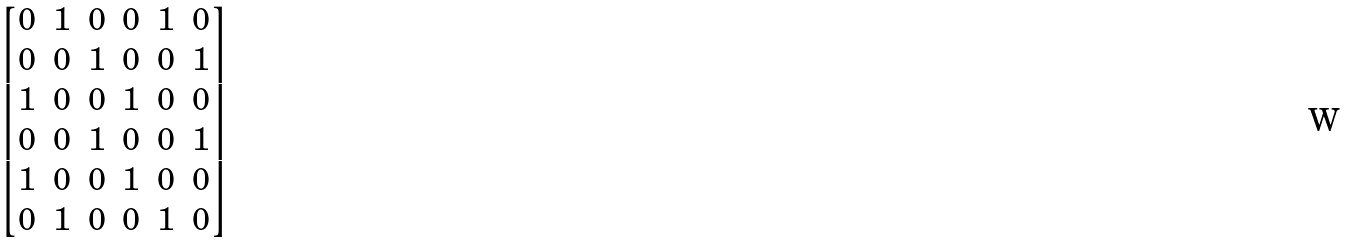Convert formula to latex. <formula><loc_0><loc_0><loc_500><loc_500>\begin{bmatrix} 0 & 1 & 0 & 0 & 1 & 0 \\ 0 & 0 & 1 & 0 & 0 & 1 \\ 1 & 0 & 0 & 1 & 0 & 0 \\ 0 & 0 & 1 & 0 & 0 & 1 \\ 1 & 0 & 0 & 1 & 0 & 0 \\ 0 & 1 & 0 & 0 & 1 & 0 \\ \end{bmatrix}</formula> 